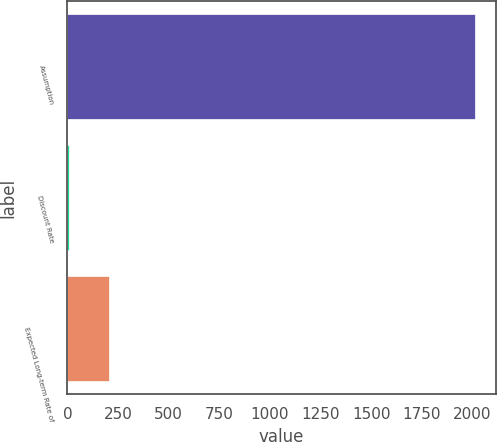Convert chart. <chart><loc_0><loc_0><loc_500><loc_500><bar_chart><fcel>Assumption<fcel>Discount Rate<fcel>Expected Long-term Rate of<nl><fcel>2014<fcel>5.3<fcel>206.17<nl></chart> 